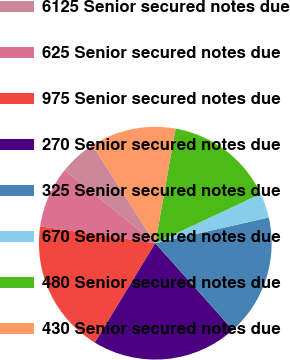Convert chart. <chart><loc_0><loc_0><loc_500><loc_500><pie_chart><fcel>6125 Senior secured notes due<fcel>625 Senior secured notes due<fcel>975 Senior secured notes due<fcel>270 Senior secured notes due<fcel>325 Senior secured notes due<fcel>670 Senior secured notes due<fcel>480 Senior secured notes due<fcel>430 Senior secured notes due<nl><fcel>5.11%<fcel>8.49%<fcel>18.62%<fcel>20.31%<fcel>16.93%<fcel>3.42%<fcel>15.24%<fcel>11.87%<nl></chart> 